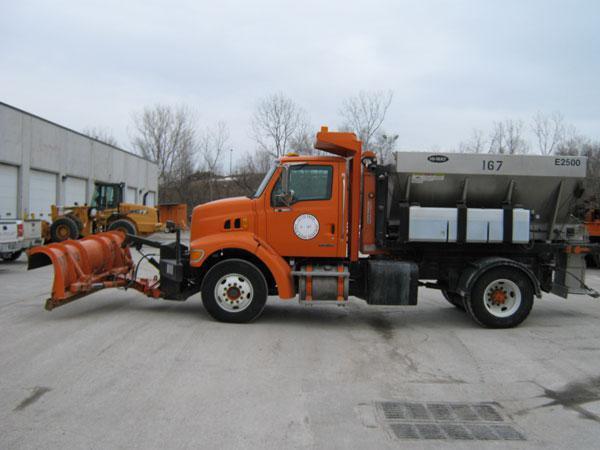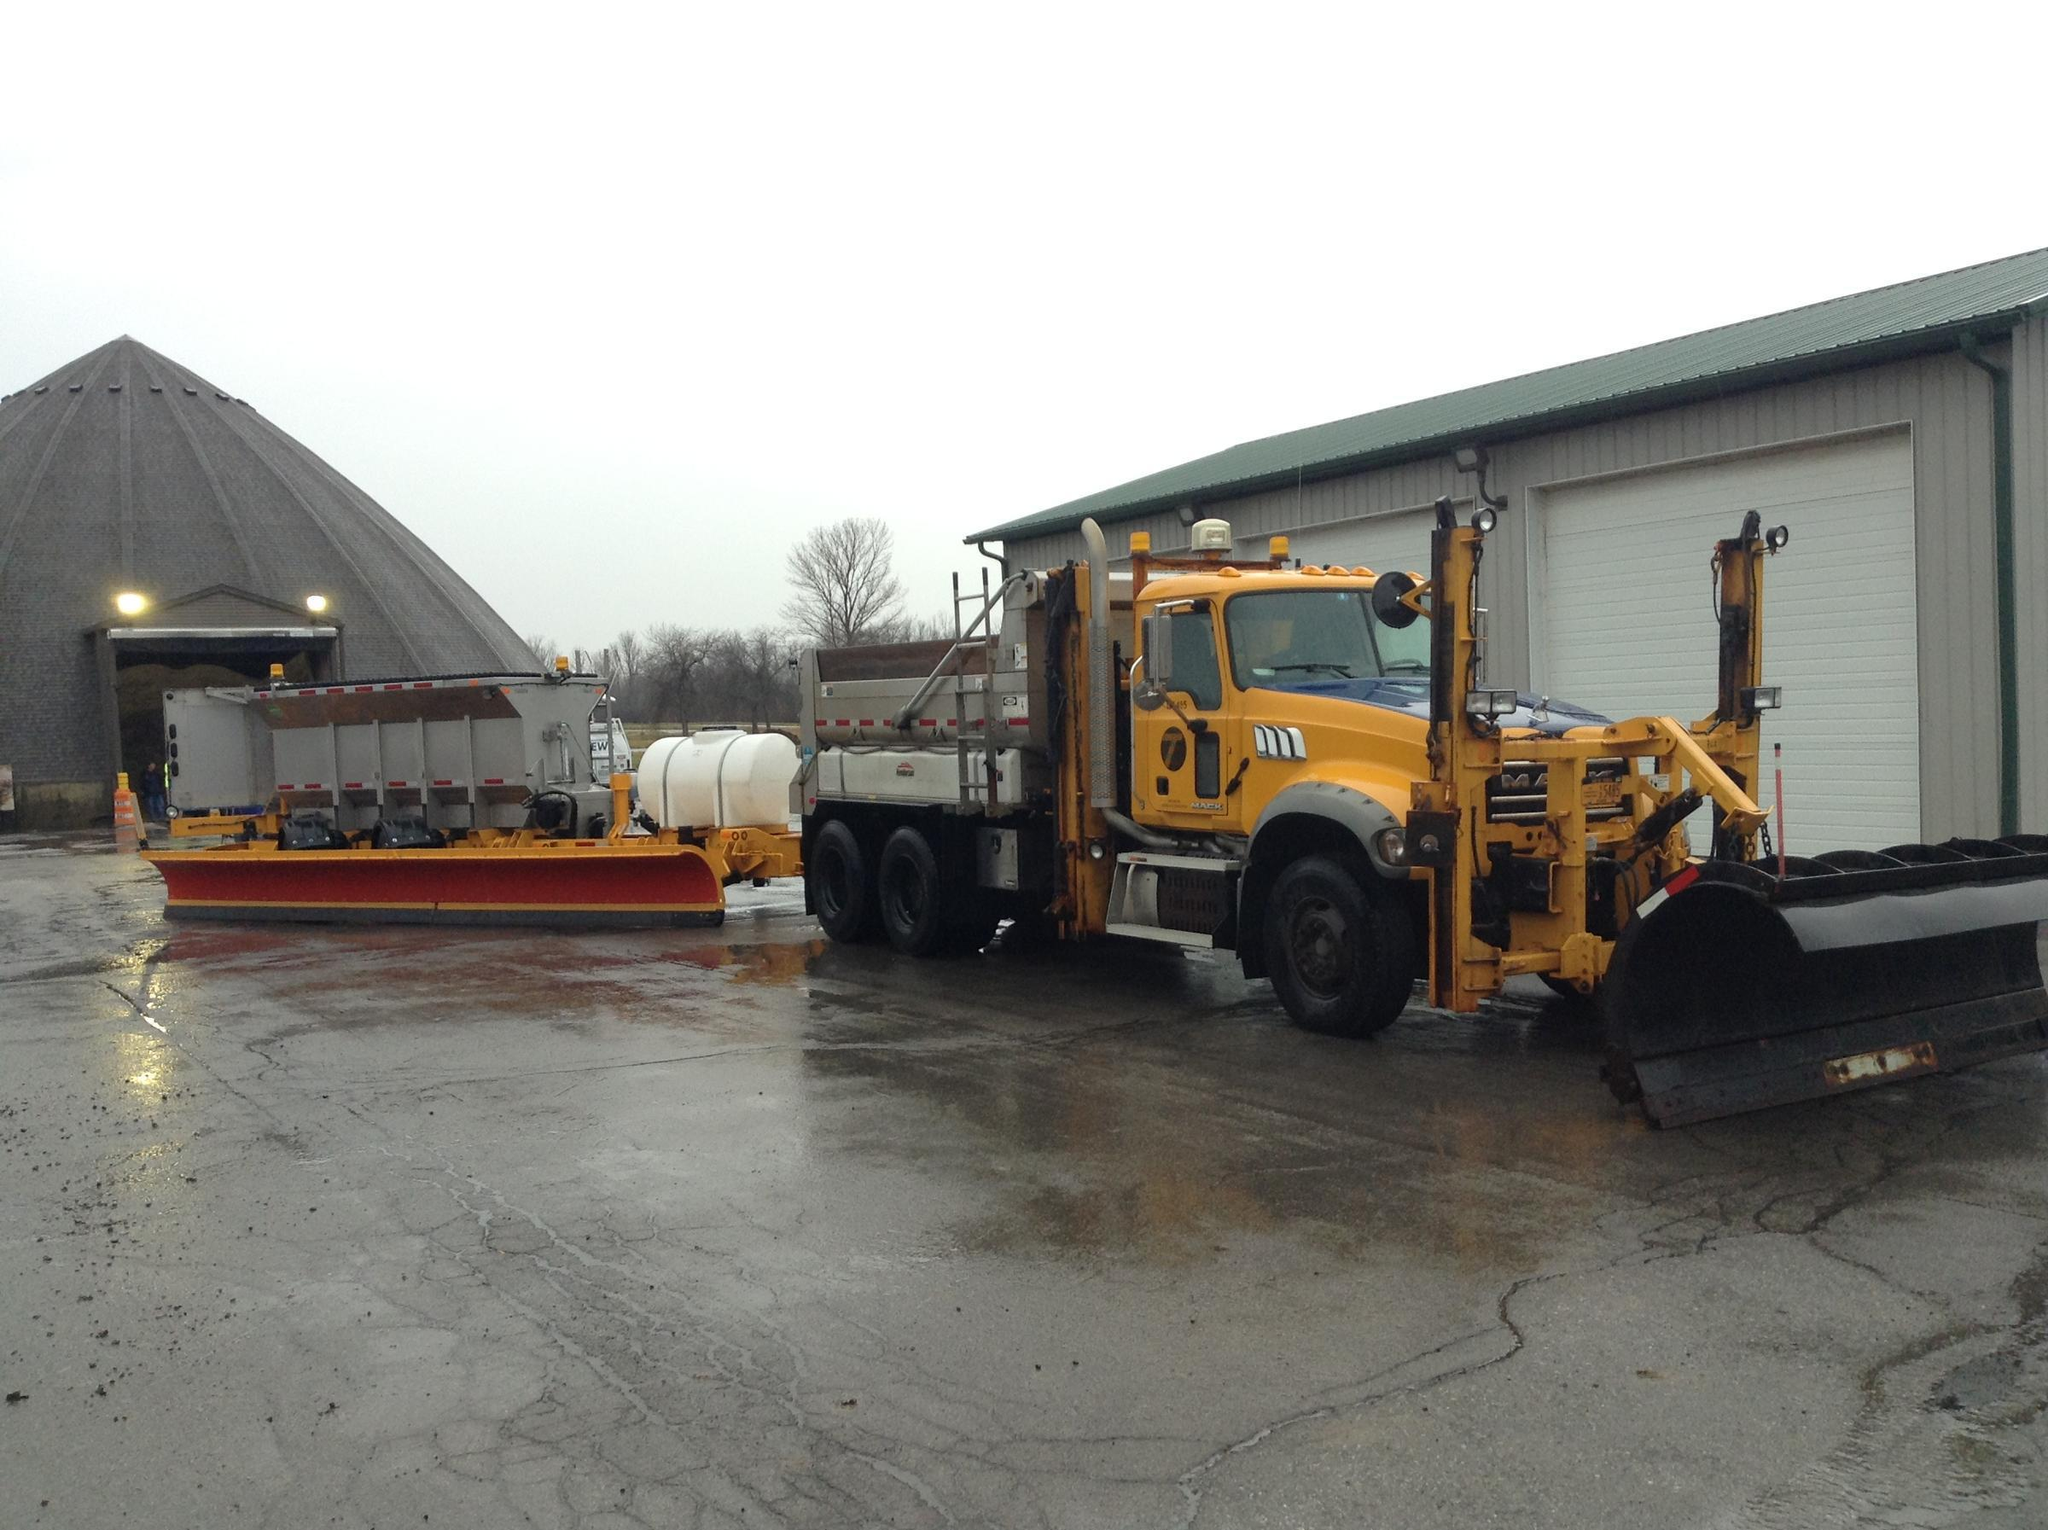The first image is the image on the left, the second image is the image on the right. For the images shown, is this caption "There are at most 3 trucks total." true? Answer yes or no. No. 